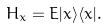<formula> <loc_0><loc_0><loc_500><loc_500>H _ { x } = E | x \rangle \langle x | .</formula> 